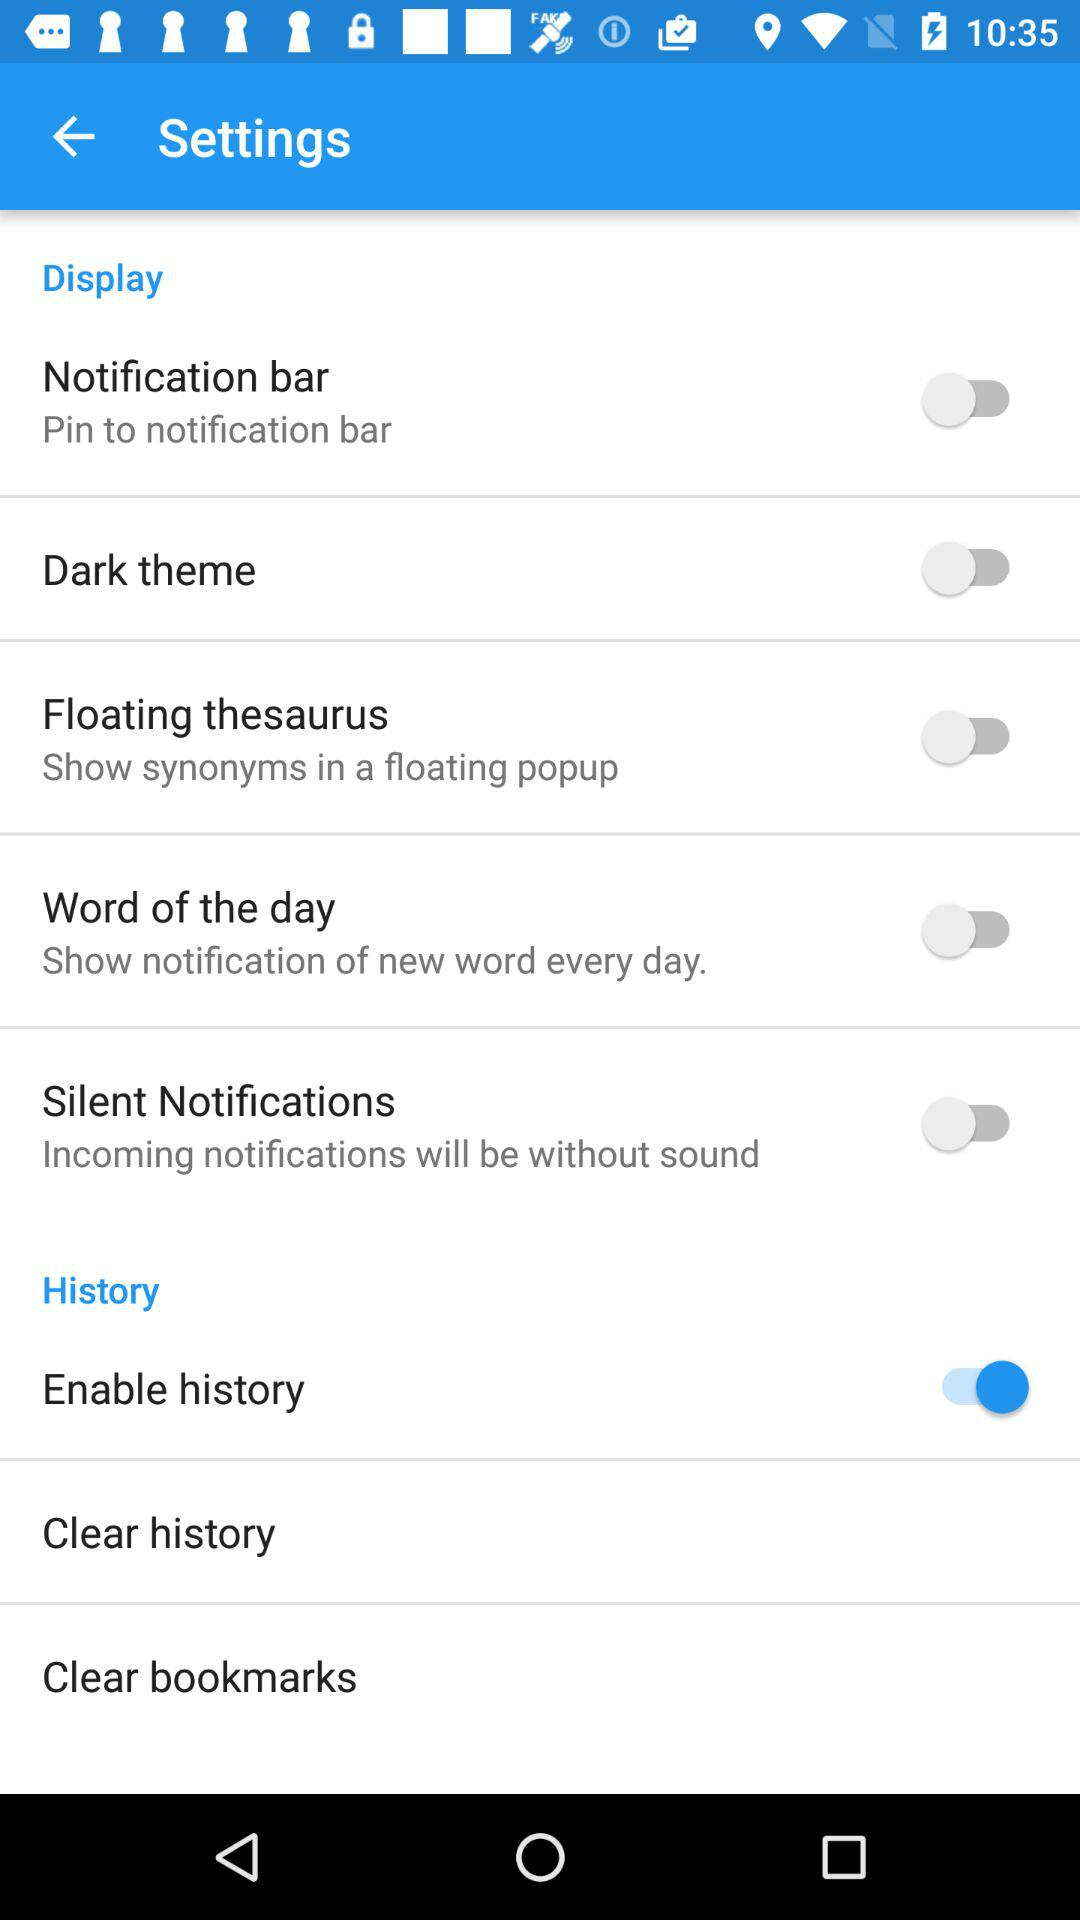What is the status of the dark theme? The status is off. 